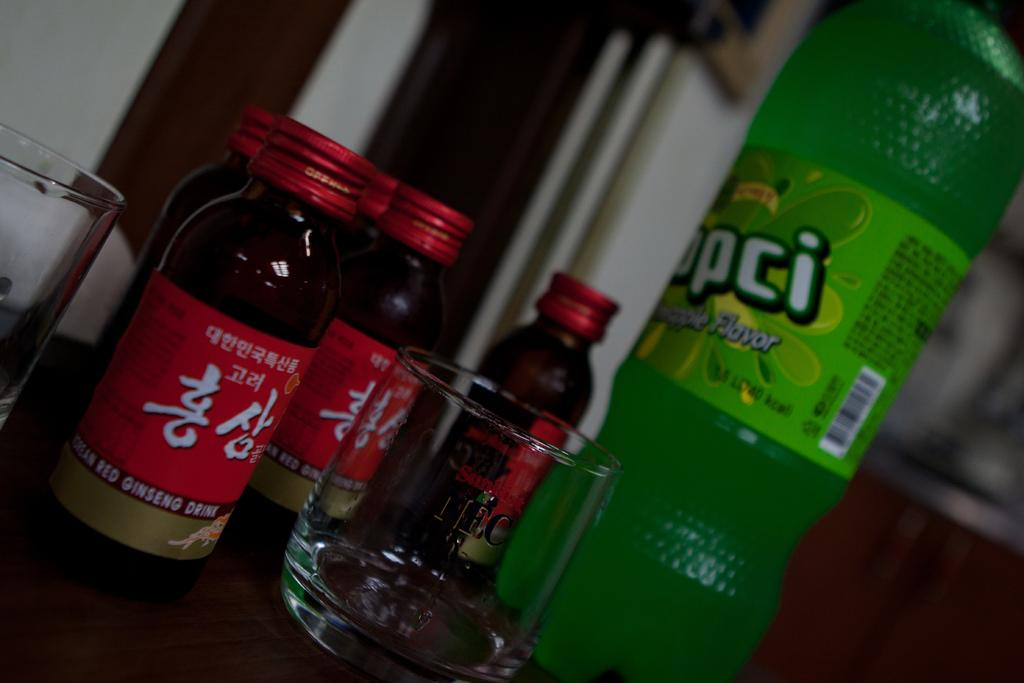Provide a one-sentence caption for the provided image. some bottles of KOREAN RED GINSENG DRINK, a small Sunkist glass and a green bottle of another drink. 